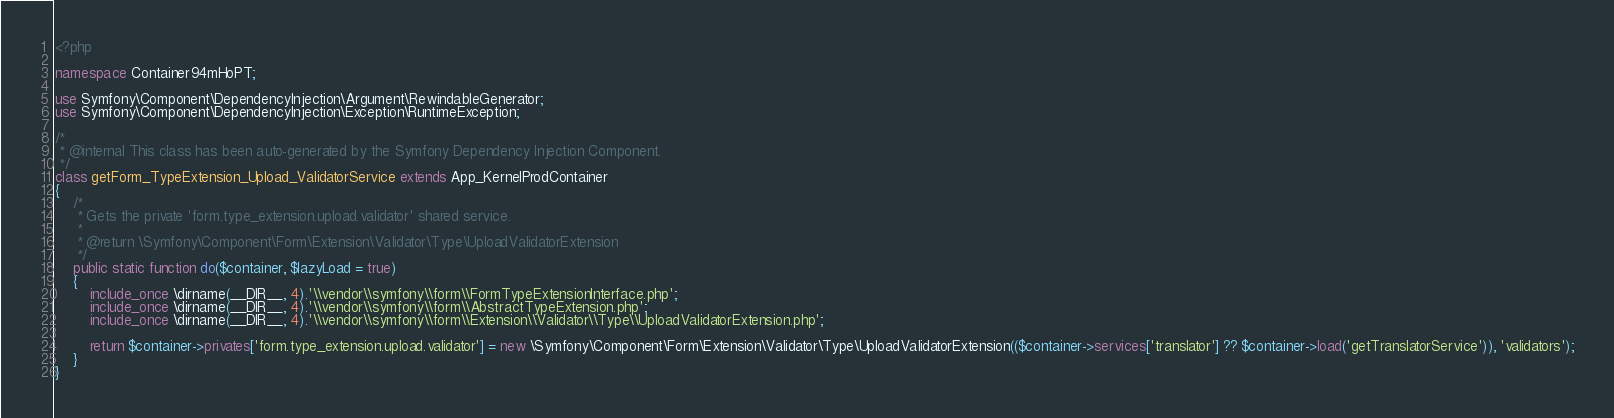Convert code to text. <code><loc_0><loc_0><loc_500><loc_500><_PHP_><?php

namespace Container94mHoPT;

use Symfony\Component\DependencyInjection\Argument\RewindableGenerator;
use Symfony\Component\DependencyInjection\Exception\RuntimeException;

/*
 * @internal This class has been auto-generated by the Symfony Dependency Injection Component.
 */
class getForm_TypeExtension_Upload_ValidatorService extends App_KernelProdContainer
{
    /*
     * Gets the private 'form.type_extension.upload.validator' shared service.
     *
     * @return \Symfony\Component\Form\Extension\Validator\Type\UploadValidatorExtension
     */
    public static function do($container, $lazyLoad = true)
    {
        include_once \dirname(__DIR__, 4).'\\vendor\\symfony\\form\\FormTypeExtensionInterface.php';
        include_once \dirname(__DIR__, 4).'\\vendor\\symfony\\form\\AbstractTypeExtension.php';
        include_once \dirname(__DIR__, 4).'\\vendor\\symfony\\form\\Extension\\Validator\\Type\\UploadValidatorExtension.php';

        return $container->privates['form.type_extension.upload.validator'] = new \Symfony\Component\Form\Extension\Validator\Type\UploadValidatorExtension(($container->services['translator'] ?? $container->load('getTranslatorService')), 'validators');
    }
}
</code> 